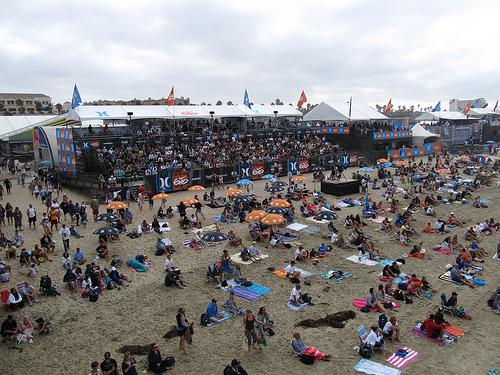Question: what are these people doing?
Choices:
A. Standing up.
B. Sitting in the grass.
C. Walking.
D. Running.
Answer with the letter. Answer: B Question: who is on the stands?
Choices:
A. Kids.
B. Teachers.
C. Animals.
D. People.
Answer with the letter. Answer: D Question: what is going on on the photo?
Choices:
A. Concert.
B. Circus.
C. Party.
D. Celebration.
Answer with the letter. Answer: A 